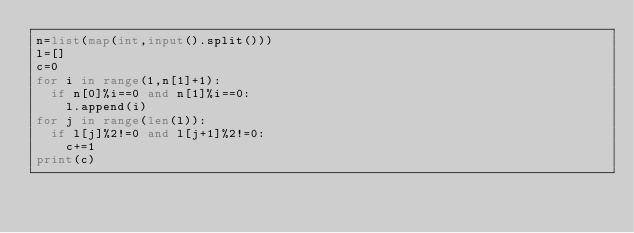Convert code to text. <code><loc_0><loc_0><loc_500><loc_500><_Python_>n=list(map(int,input().split()))
l=[]
c=0
for i in range(1,n[1]+1):
  if n[0]%i==0 and n[1]%i==0:
    l.append(i)
for j in range(len(l)):
  if l[j]%2!=0 and l[j+1]%2!=0:
    c+=1
print(c)    
    
    
    
  </code> 